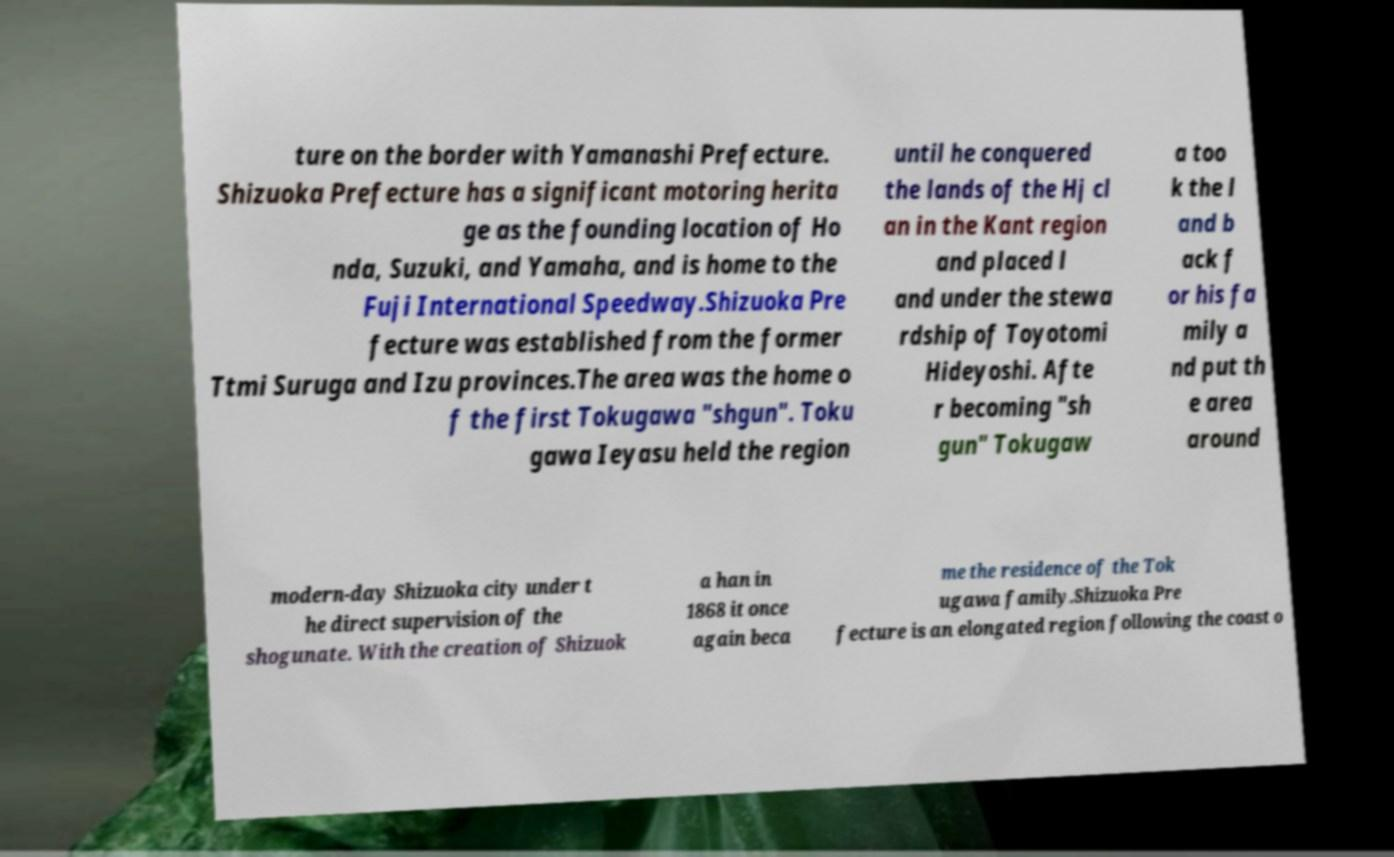There's text embedded in this image that I need extracted. Can you transcribe it verbatim? ture on the border with Yamanashi Prefecture. Shizuoka Prefecture has a significant motoring herita ge as the founding location of Ho nda, Suzuki, and Yamaha, and is home to the Fuji International Speedway.Shizuoka Pre fecture was established from the former Ttmi Suruga and Izu provinces.The area was the home o f the first Tokugawa "shgun". Toku gawa Ieyasu held the region until he conquered the lands of the Hj cl an in the Kant region and placed l and under the stewa rdship of Toyotomi Hideyoshi. Afte r becoming "sh gun" Tokugaw a too k the l and b ack f or his fa mily a nd put th e area around modern-day Shizuoka city under t he direct supervision of the shogunate. With the creation of Shizuok a han in 1868 it once again beca me the residence of the Tok ugawa family.Shizuoka Pre fecture is an elongated region following the coast o 